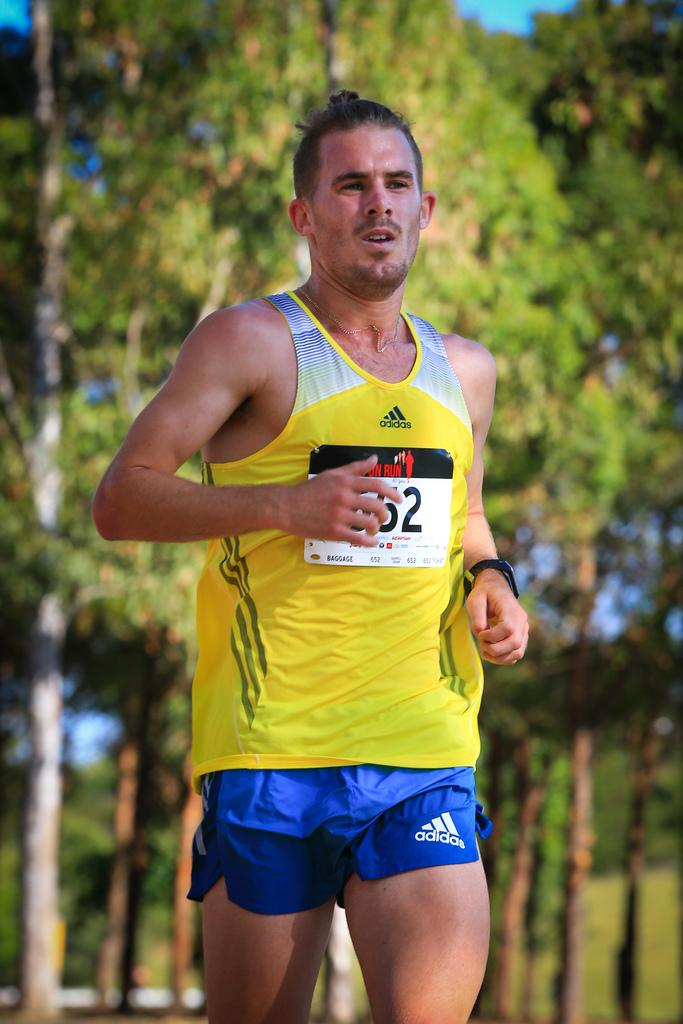<image>
Offer a succinct explanation of the picture presented. A man is running in blue shorts and an Adidas shirt. 